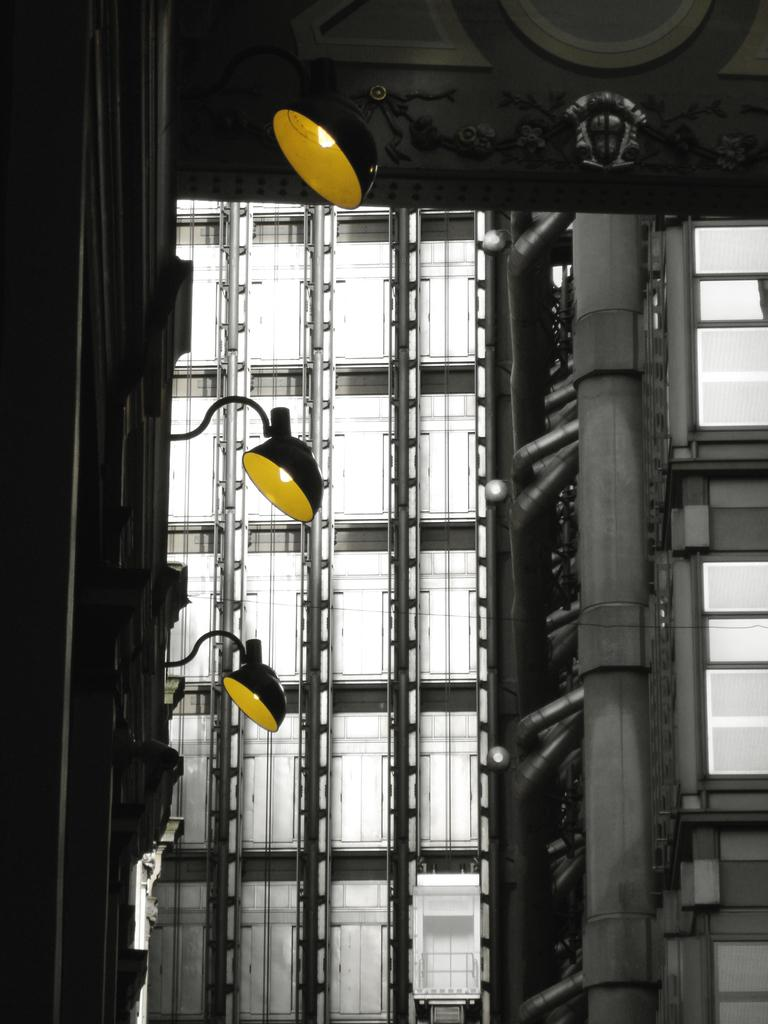What can be seen in the image that provides illumination? There is a group of lights in the image. What type of structures are visible in the image? There are buildings in the image. What are the tall, slender objects in the image? There are poles in the image. How many dolls are sitting on the quilt in the image? There are no dolls or quilts present in the image. What type of geese can be seen flying in the image? There are no geese visible in the image. 